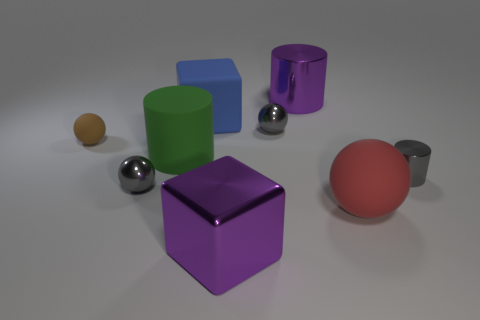There is a thing that is the same color as the shiny block; what material is it?
Make the answer very short. Metal. How many other things are the same color as the small cylinder?
Provide a succinct answer. 2. Does the small ball in front of the green cylinder have the same color as the big metallic cylinder?
Your answer should be compact. No. There is a shiny object that is to the left of the big blue thing; is there a big shiny cylinder in front of it?
Provide a short and direct response. No. What is the cylinder that is both in front of the purple cylinder and on the left side of the red thing made of?
Ensure brevity in your answer.  Rubber. What shape is the tiny thing that is the same material as the big red object?
Your answer should be compact. Sphere. Are there any other things that are the same shape as the red thing?
Make the answer very short. Yes. Do the cylinder right of the large ball and the red object have the same material?
Offer a terse response. No. There is a sphere behind the tiny brown sphere; what is it made of?
Give a very brief answer. Metal. There is a gray metallic sphere that is to the right of the big cube that is in front of the large red thing; how big is it?
Give a very brief answer. Small. 